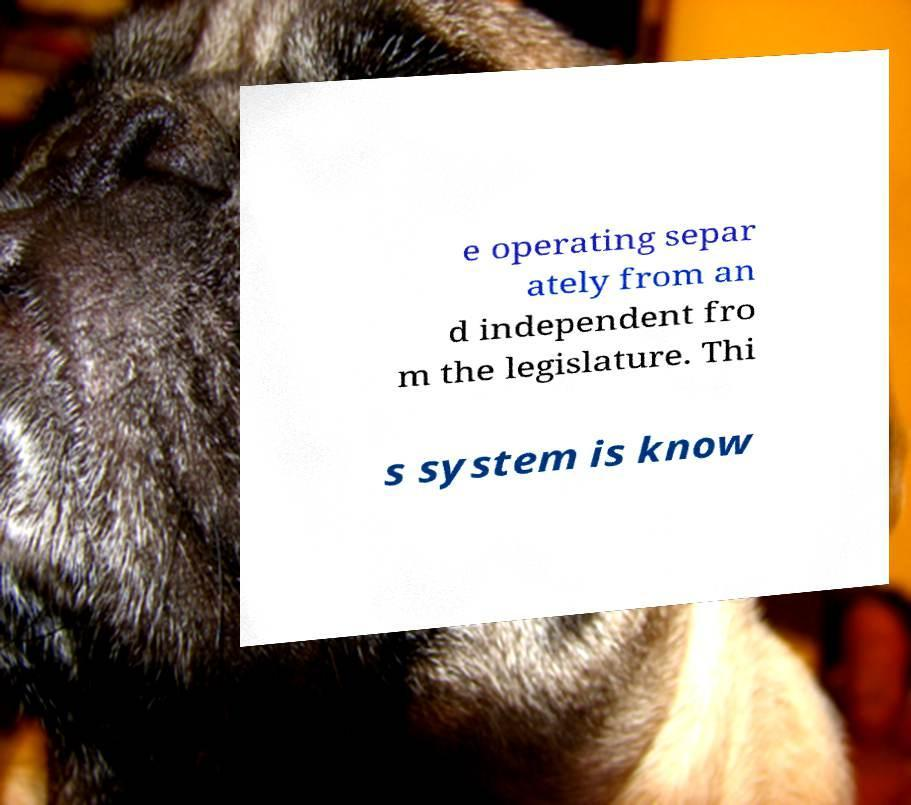Please read and relay the text visible in this image. What does it say? e operating separ ately from an d independent fro m the legislature. Thi s system is know 